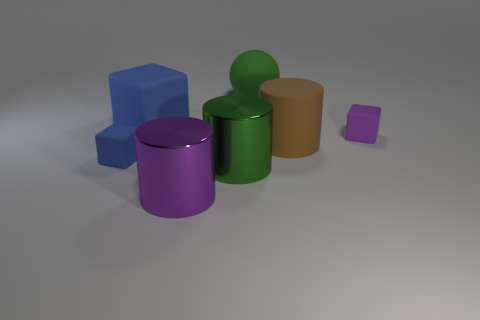There is a blue thing that is the same size as the purple block; what shape is it?
Your answer should be very brief. Cube. What is the material of the green object behind the purple thing that is behind the blue block in front of the purple cube?
Give a very brief answer. Rubber. Does the blue object that is to the left of the large blue thing have the same shape as the purple thing that is left of the large ball?
Provide a short and direct response. No. How many other objects are there of the same material as the tiny blue block?
Provide a short and direct response. 4. Does the large green ball right of the big cube have the same material as the green thing in front of the sphere?
Provide a short and direct response. No. What shape is the object that is the same material as the purple cylinder?
Offer a very short reply. Cylinder. Is there any other thing that is the same color as the matte sphere?
Offer a very short reply. Yes. How many cyan objects are there?
Provide a short and direct response. 0. What is the shape of the matte object that is on the left side of the purple metal thing and behind the big rubber cylinder?
Make the answer very short. Cube. There is a large matte thing in front of the tiny cube that is behind the blue cube in front of the small purple matte cube; what shape is it?
Ensure brevity in your answer.  Cylinder. 